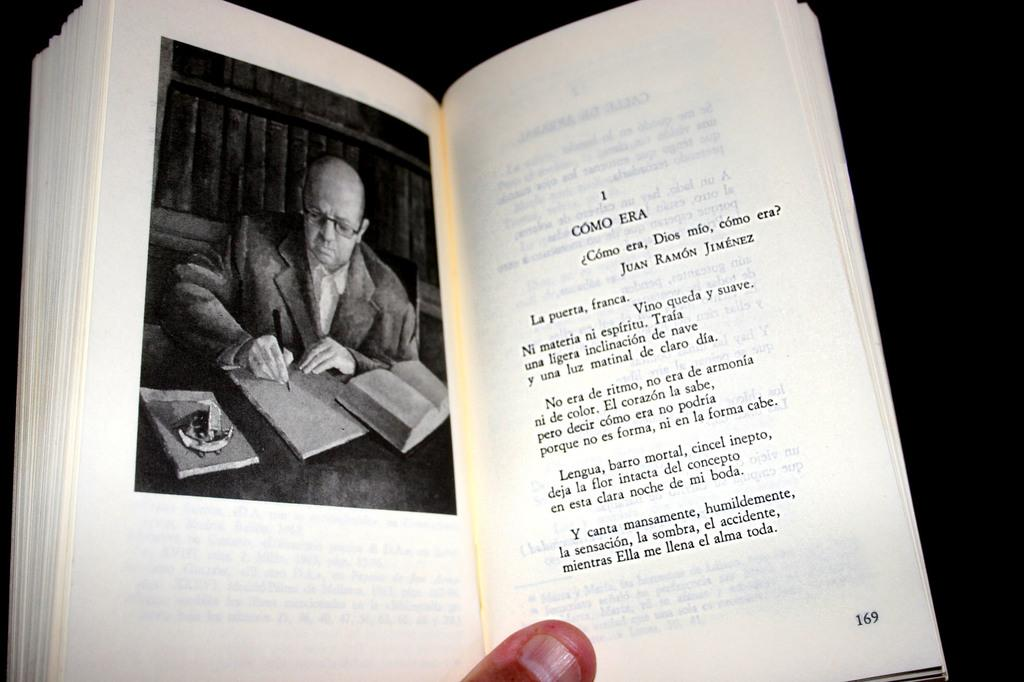<image>
Share a concise interpretation of the image provided. A book that is opened to page 169. 